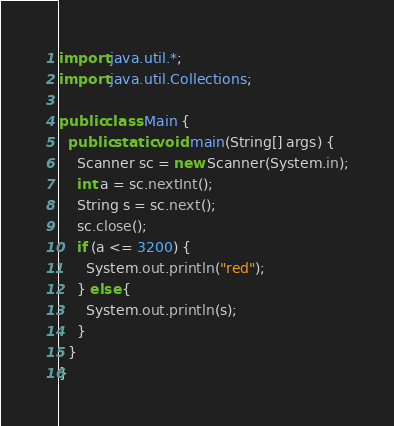Convert code to text. <code><loc_0><loc_0><loc_500><loc_500><_Java_>import java.util.*;
import java.util.Collections;

public class Main {
  public static void main(String[] args) {
    Scanner sc = new Scanner(System.in);
    int a = sc.nextInt();
    String s = sc.next();
    sc.close();
    if (a <= 3200) {
      System.out.println("red");
    } else {
      System.out.println(s);
    }
  }
}
</code> 